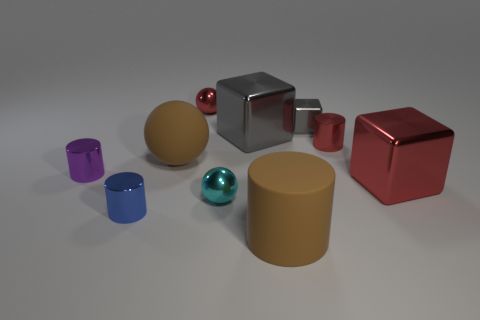What number of gray things are either big shiny things or metal spheres?
Give a very brief answer. 1. What number of other things are there of the same size as the brown matte ball?
Your answer should be compact. 3. What number of tiny objects are either shiny objects or brown balls?
Provide a succinct answer. 6. Is the size of the brown matte sphere the same as the metallic sphere in front of the red cylinder?
Make the answer very short. No. What number of other things are the same shape as the cyan thing?
Ensure brevity in your answer.  2. What is the shape of the object that is made of the same material as the brown ball?
Keep it short and to the point. Cylinder. Is there a big ball?
Offer a very short reply. Yes. Is the number of metal things that are in front of the red cylinder less than the number of small blue shiny cylinders that are on the left side of the blue metallic object?
Provide a succinct answer. No. What is the shape of the red shiny object that is in front of the small purple metallic cylinder?
Offer a very short reply. Cube. Is the large ball made of the same material as the large gray cube?
Your answer should be very brief. No. 